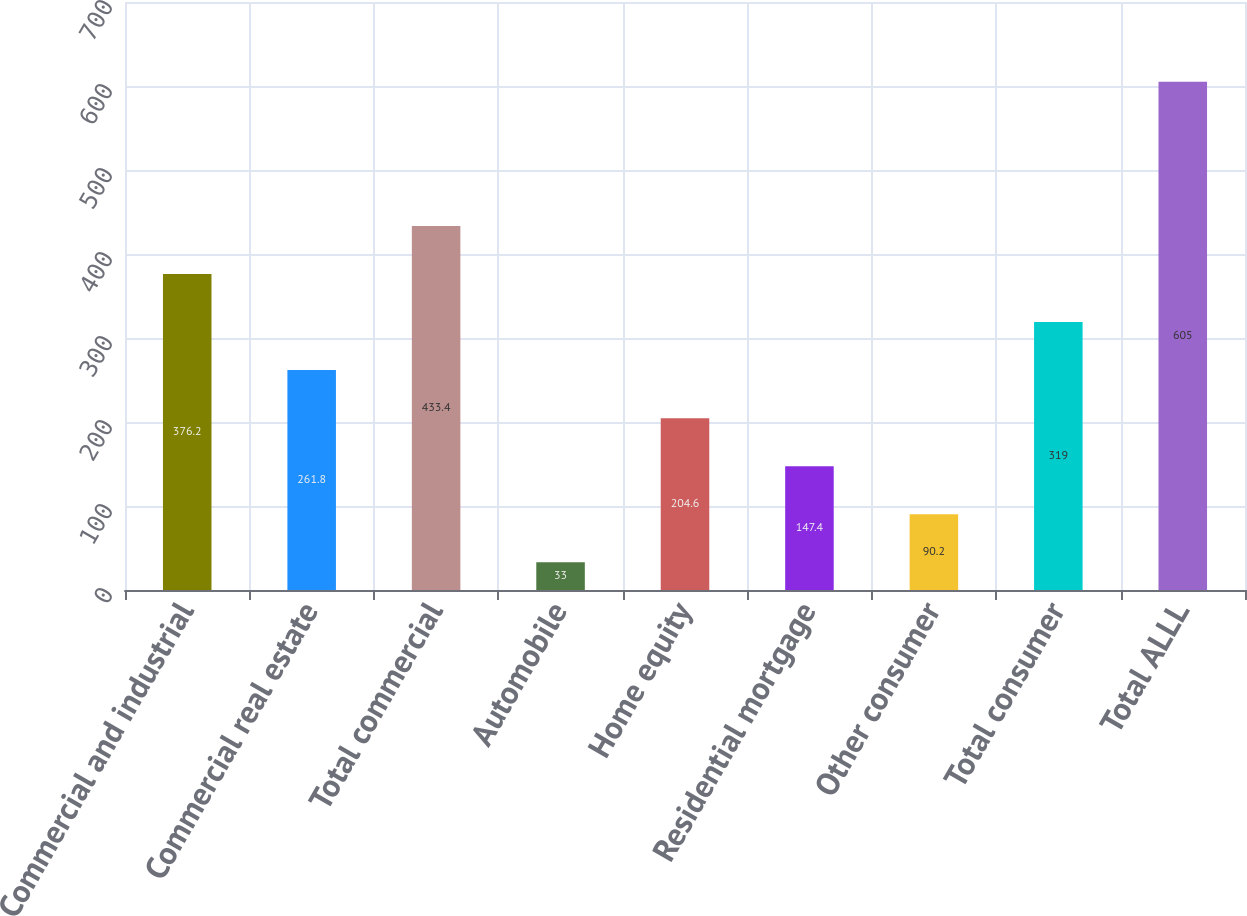<chart> <loc_0><loc_0><loc_500><loc_500><bar_chart><fcel>Commercial and industrial<fcel>Commercial real estate<fcel>Total commercial<fcel>Automobile<fcel>Home equity<fcel>Residential mortgage<fcel>Other consumer<fcel>Total consumer<fcel>Total ALLL<nl><fcel>376.2<fcel>261.8<fcel>433.4<fcel>33<fcel>204.6<fcel>147.4<fcel>90.2<fcel>319<fcel>605<nl></chart> 